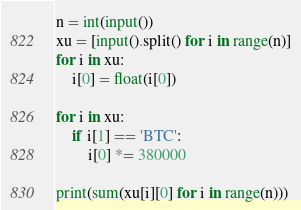<code> <loc_0><loc_0><loc_500><loc_500><_Python_>n = int(input())
xu = [input().split() for i in range(n)]
for i in xu:
    i[0] = float(i[0])

for i in xu:
    if i[1] == 'BTC':
        i[0] *= 380000

print(sum(xu[i][0] for i in range(n)))</code> 